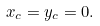Convert formula to latex. <formula><loc_0><loc_0><loc_500><loc_500>x _ { c } = y _ { c } = 0 .</formula> 